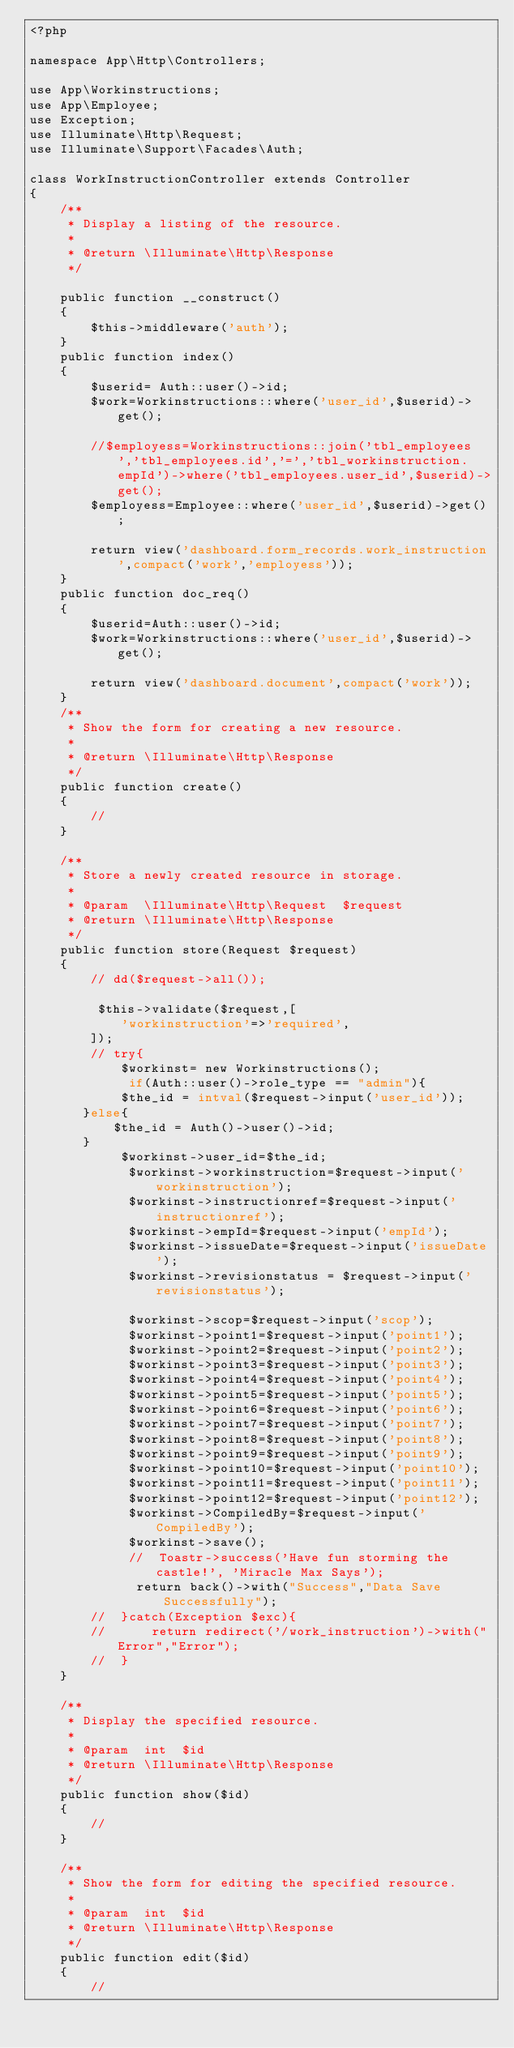Convert code to text. <code><loc_0><loc_0><loc_500><loc_500><_PHP_><?php

namespace App\Http\Controllers;

use App\Workinstructions;
use App\Employee;
use Exception;
use Illuminate\Http\Request;
use Illuminate\Support\Facades\Auth;

class WorkInstructionController extends Controller
{
    /**
     * Display a listing of the resource.
     *
     * @return \Illuminate\Http\Response
     */

    public function __construct()
    {
        $this->middleware('auth');
    }
    public function index()
    {
        $userid= Auth::user()->id;
        $work=Workinstructions::where('user_id',$userid)->get();

        //$employess=Workinstructions::join('tbl_employees','tbl_employees.id','=','tbl_workinstruction.empId')->where('tbl_employees.user_id',$userid)->get();
        $employess=Employee::where('user_id',$userid)->get();

        return view('dashboard.form_records.work_instruction',compact('work','employess'));
    }
    public function doc_req()
    {
        $userid=Auth::user()->id;
        $work=Workinstructions::where('user_id',$userid)->get();
        
        return view('dashboard.document',compact('work'));
    }
    /**
     * Show the form for creating a new resource.
     *
     * @return \Illuminate\Http\Response
     */
    public function create()
    {
        //
    }

    /**
     * Store a newly created resource in storage.
     *
     * @param  \Illuminate\Http\Request  $request
     * @return \Illuminate\Http\Response
     */
    public function store(Request $request)
    {
        // dd($request->all());
         
         $this->validate($request,[
            'workinstruction'=>'required',
        ]);
        // try{
            $workinst= new Workinstructions();
             if(Auth::user()->role_type == "admin"){
            $the_id = intval($request->input('user_id'));
       }else{
           $the_id = Auth()->user()->id;
       }    
            $workinst->user_id=$the_id;
             $workinst->workinstruction=$request->input('workinstruction');
             $workinst->instructionref=$request->input('instructionref');
             $workinst->empId=$request->input('empId');
             $workinst->issueDate=$request->input('issueDate');
             $workinst->revisionstatus = $request->input('revisionstatus');
             
             $workinst->scop=$request->input('scop');
             $workinst->point1=$request->input('point1');
             $workinst->point2=$request->input('point2');
             $workinst->point3=$request->input('point3');
             $workinst->point4=$request->input('point4');
             $workinst->point5=$request->input('point5');
             $workinst->point6=$request->input('point6');
             $workinst->point7=$request->input('point7');
             $workinst->point8=$request->input('point8');
             $workinst->point9=$request->input('point9');
             $workinst->point10=$request->input('point10');
             $workinst->point11=$request->input('point11');
             $workinst->point12=$request->input('point12');
             $workinst->CompiledBy=$request->input('CompiledBy');
             $workinst->save();
             //  Toastr->success('Have fun storming the castle!', 'Miracle Max Says');
              return back()->with("Success","Data Save Successfully");
        //  }catch(Exception $exc){
        //      return redirect('/work_instruction')->with("Error","Error");
        //  }
    }

    /**
     * Display the specified resource.
     *
     * @param  int  $id
     * @return \Illuminate\Http\Response
     */
    public function show($id)
    {
        //
    }

    /**
     * Show the form for editing the specified resource.
     *
     * @param  int  $id
     * @return \Illuminate\Http\Response
     */
    public function edit($id)
    {
        //</code> 